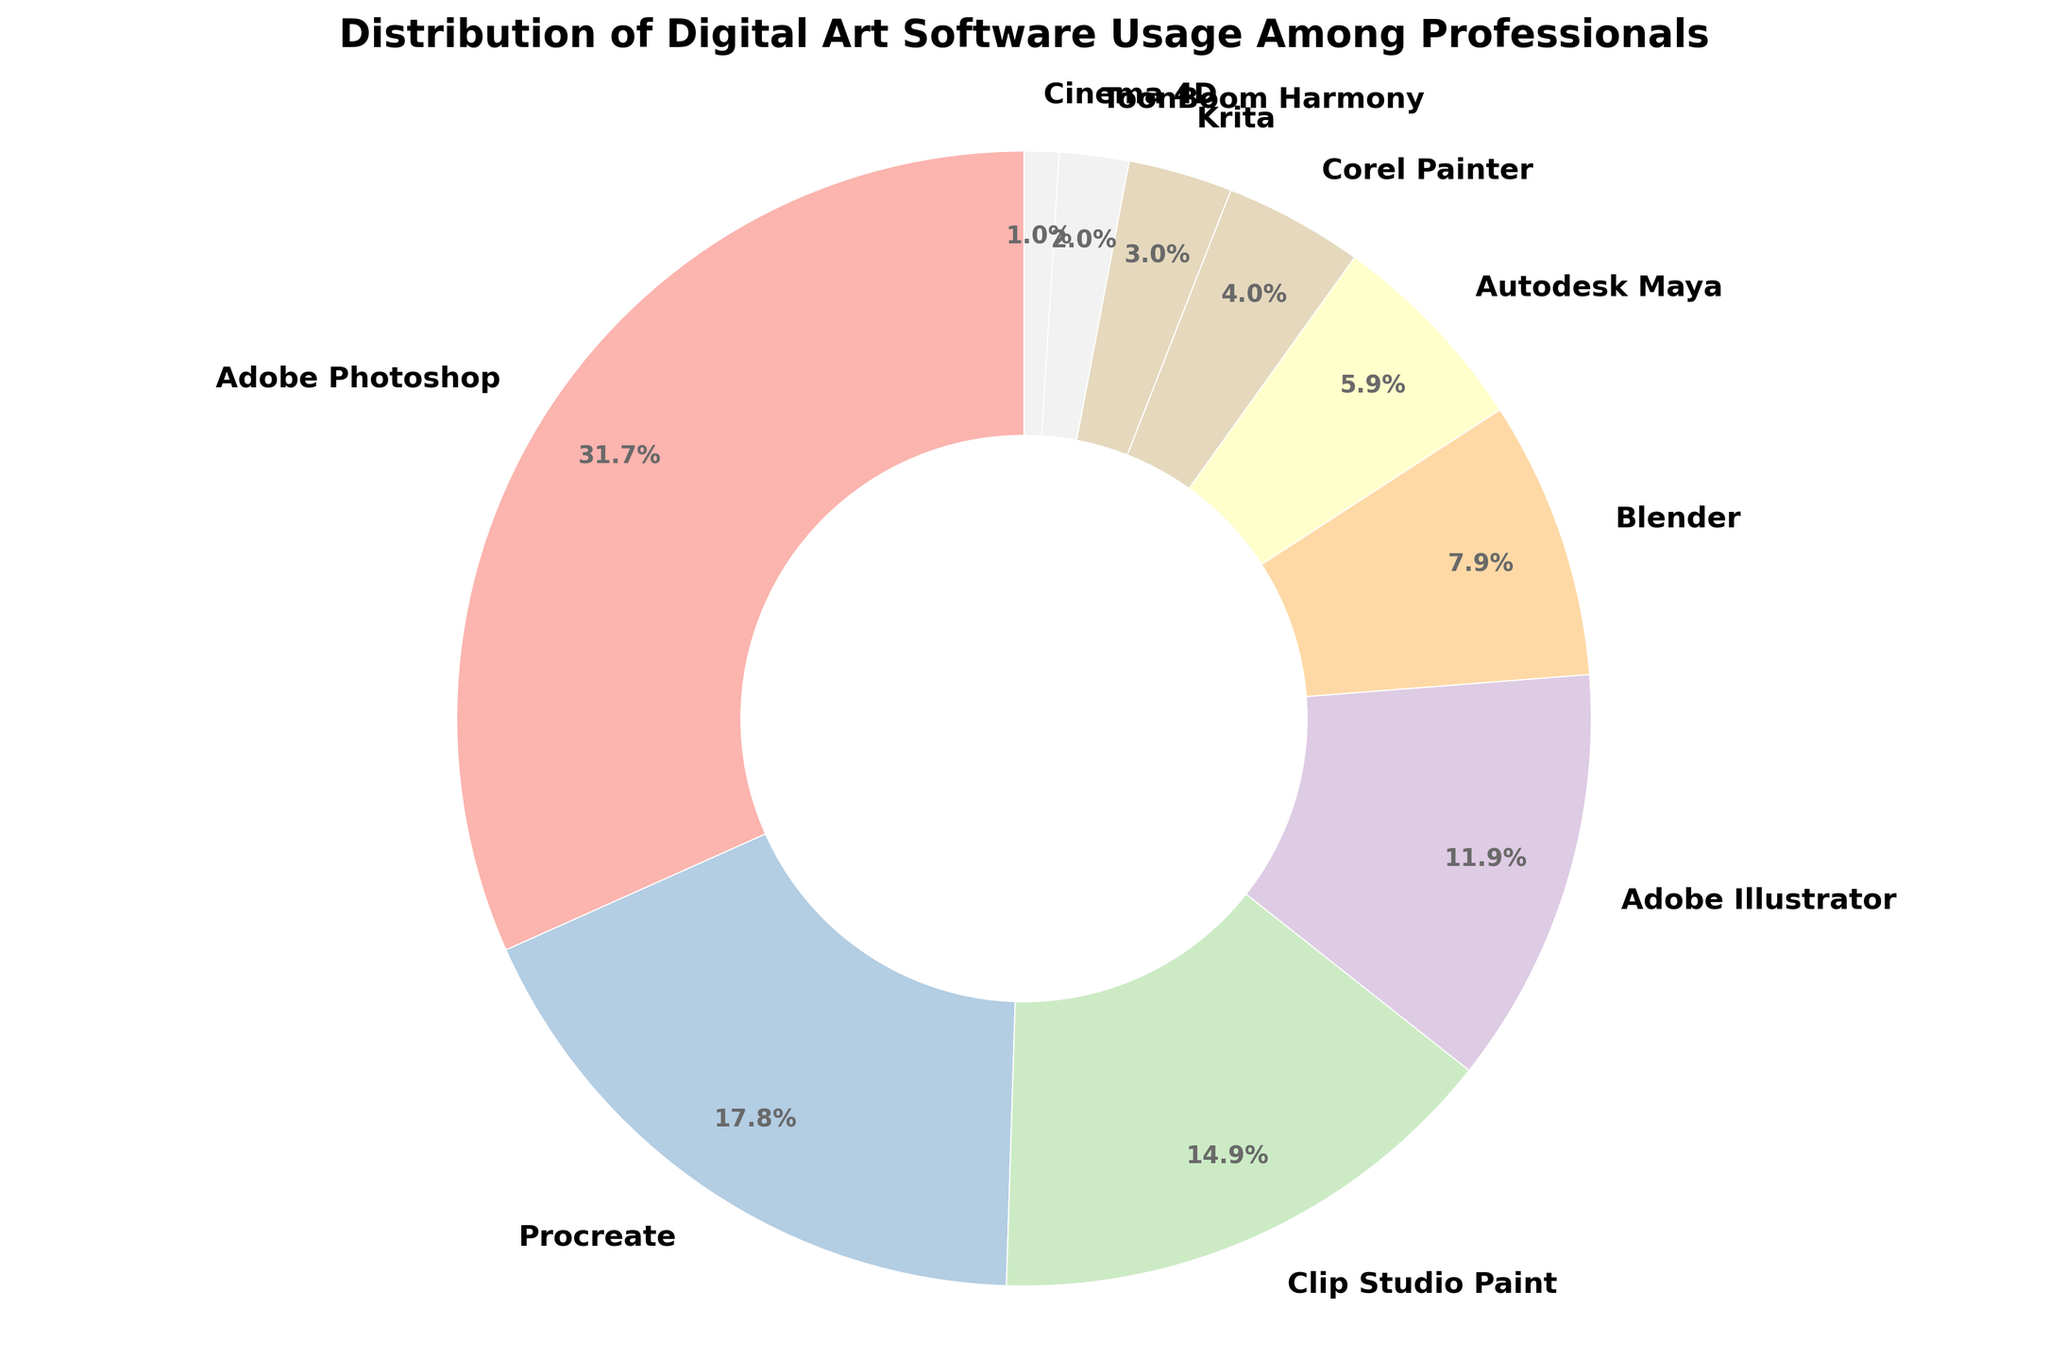Which software has the highest usage percentage? The pie chart shows the different software tools used by professionals along with their usage percentages. By observing the chart, we can see that Adobe Photoshop has the largest segment.
Answer: Adobe Photoshop What is the combined percentage of usage for Procreate and Clip Studio Paint? To find the combined percentage, we sum the percentages of Procreate (18%) and Clip Studio Paint (15%). 18% + 15% = 33%.
Answer: 33% Which has a greater percentage use, Blender or Autodesk Maya? By checking the pie chart's segments, we compare Blender (8%) with Autodesk Maya (6%). Blender has a higher percentage.
Answer: Blender What is the total percentage of usage for all Adobe products listed? From the chart, we identify Adobe products: Adobe Photoshop (32%) and Adobe Illustrator (12%). Adding these gives 32% + 12% = 44%.
Answer: 44% What is the difference in usage percentage between the most used and the least used software? The most used software is Adobe Photoshop (32%) and the least used is Cinema 4D (1%). The difference is 32% - 1% = 31%.
Answer: 31% Which software has exactly two digits' of usage percentage and more than 10%? By looking at the segments with two-digit percentages, we see Adobe Photoshop (32%), Procreate (18%), Clip Studio Paint (15%), and Adobe Illustrator (12%). Among these, more than 10% are 32%, 18%, 15%, and 12%. But the condition is more than 10%, so excluding 12%
Answer: Adobe Illustrator How many software options have a single-digit usage percentage? By visually inspecting the segments, the single-digit percentages are Blender (8%), Autodesk Maya (6%), Corel Painter (4%), Krita (3%), ToonBoom Harmony (2%), and Cinema 4D (1%). There are 6 such options.
Answer: 6 Is the percentage of usage for Procreate greater than the combined usage of Krita, ToonBoom Harmony, and Cinema 4D? Procreate has a usage of 18%. Combined usage for Krita (3%), ToonBoom Harmony (2%), and Cinema 4D (1%) is 3% + 2% + 1% = 6%. 18% is greater than 6%.
Answer: Yes What percentage of software usage falls below 5%? Below 5% are Corel Painter (4%), Krita (3%), ToonBoom Harmony (2%), and Cinema 4D (1%). Summing these gives 4% + 3% + 2% + 1% = 10%.
Answer: 10% 